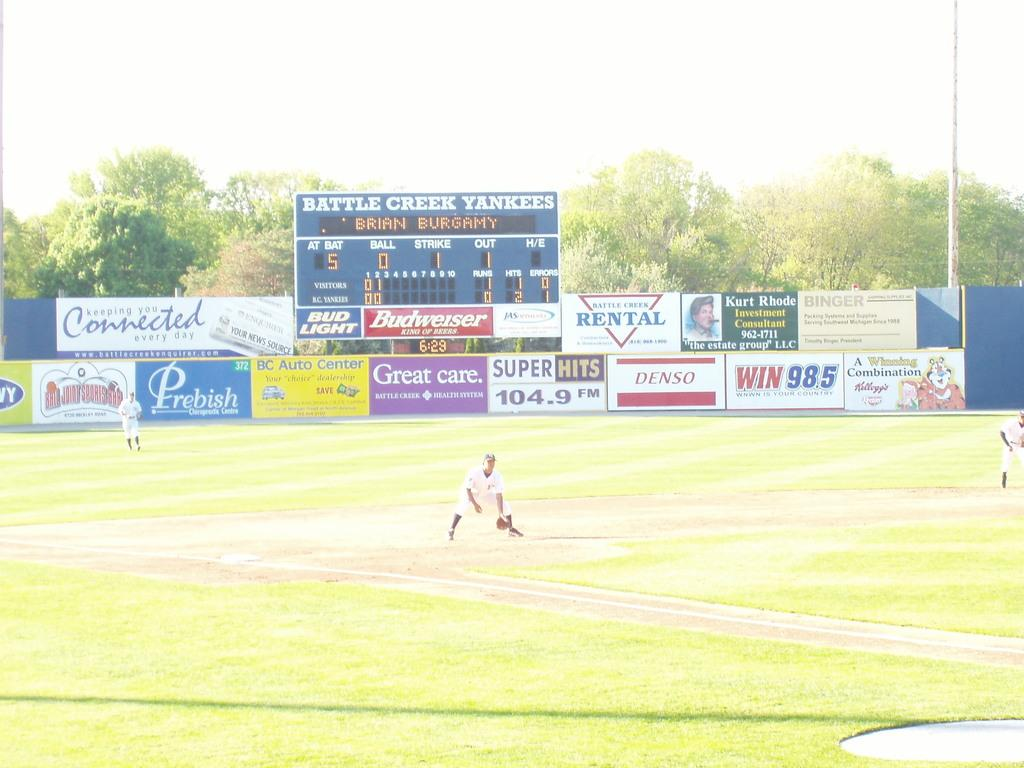<image>
Write a terse but informative summary of the picture. a field with a Yankees team name on the scoreboard 